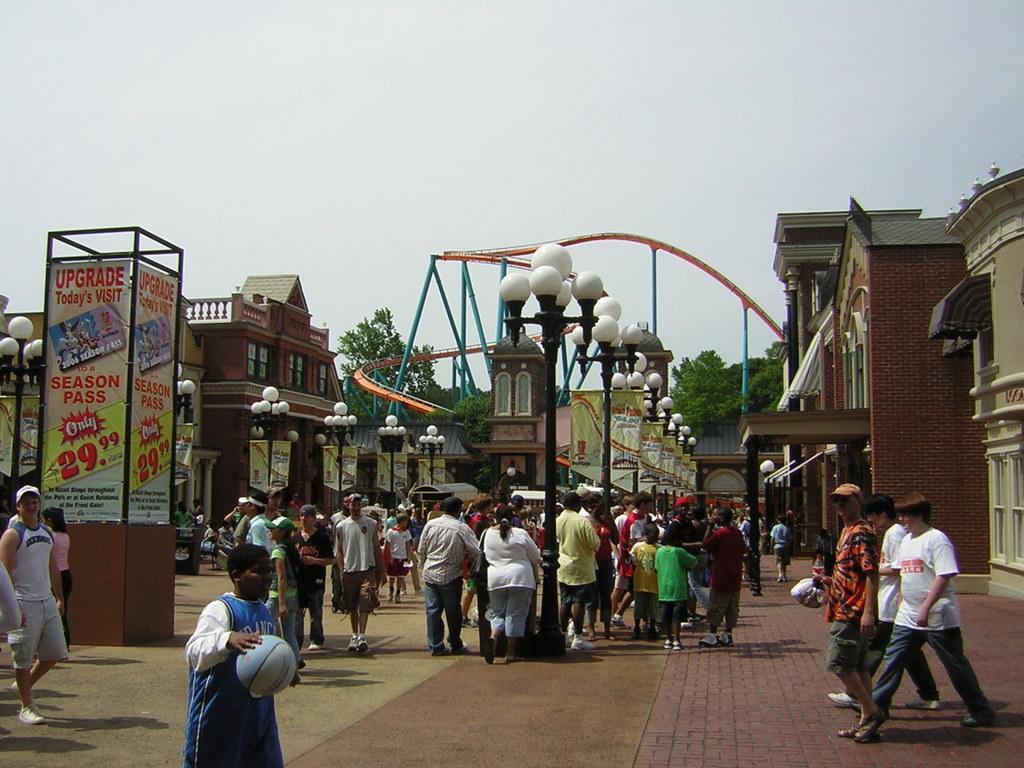Could you give a brief overview of what you see in this image? In this image, we can see a person holding a ball and in the background, there are many people and some are wearing caps and we can see lights, poles, buildings, trees, banners and a booth. At the bottom, there is a road and at the top, there is sky. 